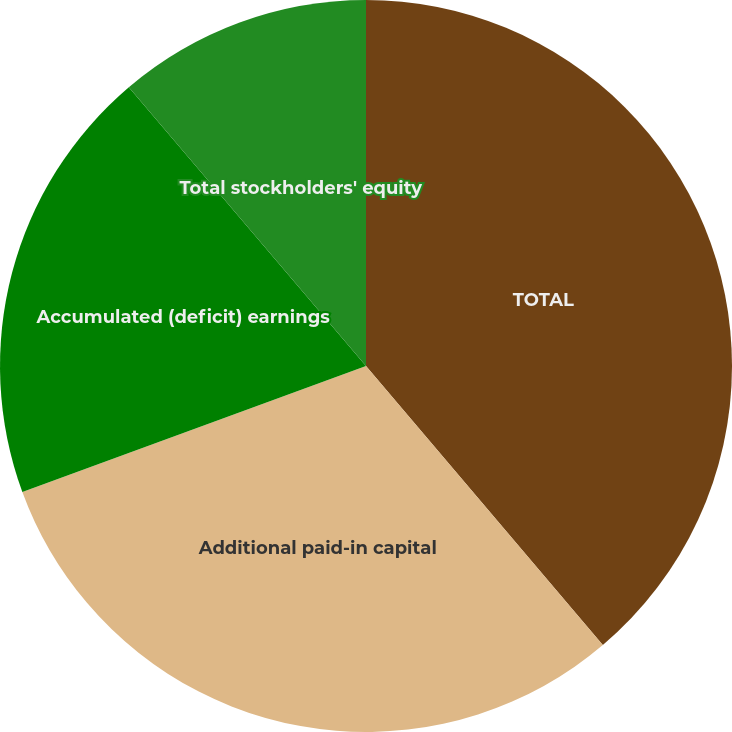Convert chart to OTSL. <chart><loc_0><loc_0><loc_500><loc_500><pie_chart><fcel>TOTAL<fcel>Additional paid-in capital<fcel>Accumulated (deficit) earnings<fcel>Total stockholders' equity<nl><fcel>38.8%<fcel>30.61%<fcel>19.37%<fcel>11.22%<nl></chart> 